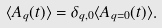Convert formula to latex. <formula><loc_0><loc_0><loc_500><loc_500>\langle A _ { q } ( t ) \rangle = \delta _ { { q } , { 0 } } \langle A _ { q = 0 } ( t ) \rangle .</formula> 